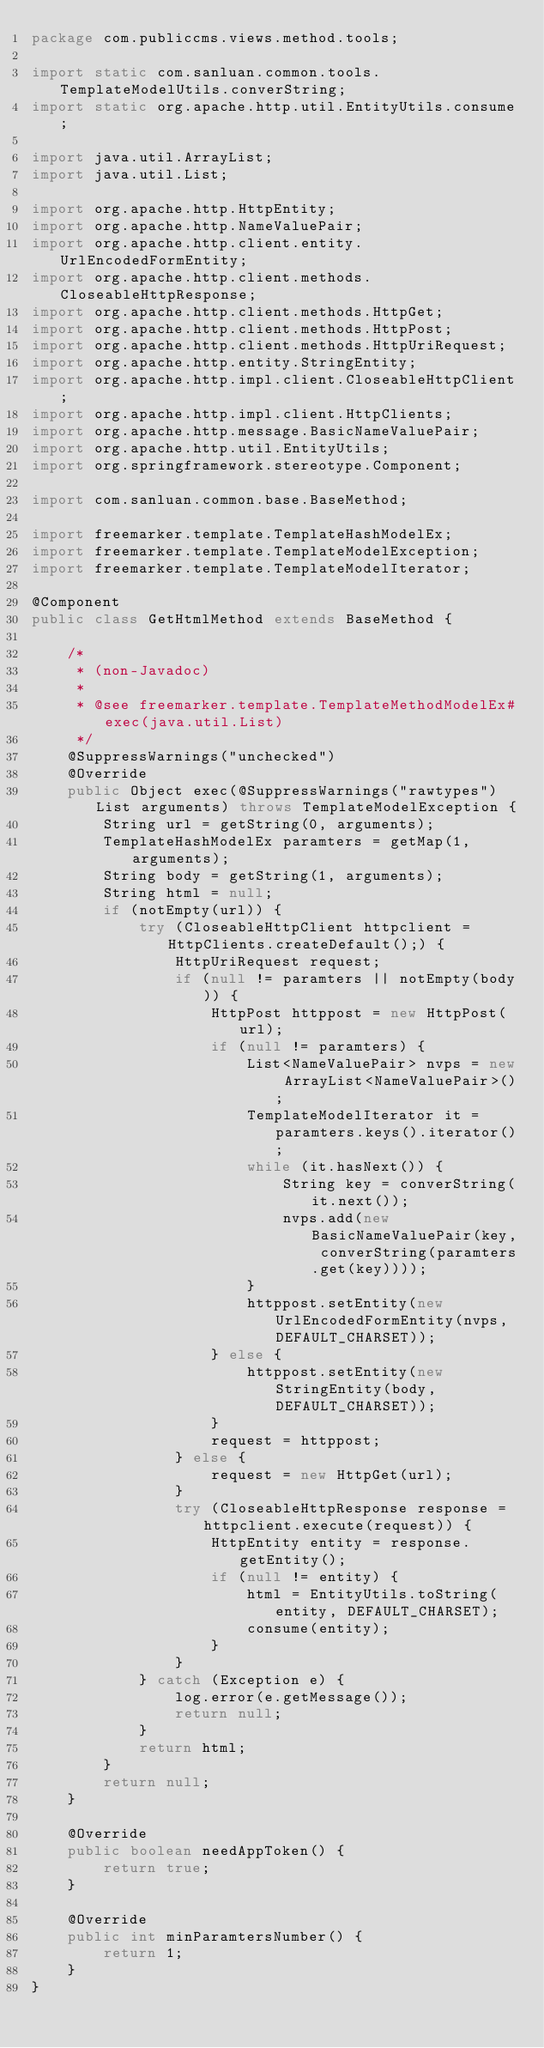<code> <loc_0><loc_0><loc_500><loc_500><_Java_>package com.publiccms.views.method.tools;

import static com.sanluan.common.tools.TemplateModelUtils.converString;
import static org.apache.http.util.EntityUtils.consume;

import java.util.ArrayList;
import java.util.List;

import org.apache.http.HttpEntity;
import org.apache.http.NameValuePair;
import org.apache.http.client.entity.UrlEncodedFormEntity;
import org.apache.http.client.methods.CloseableHttpResponse;
import org.apache.http.client.methods.HttpGet;
import org.apache.http.client.methods.HttpPost;
import org.apache.http.client.methods.HttpUriRequest;
import org.apache.http.entity.StringEntity;
import org.apache.http.impl.client.CloseableHttpClient;
import org.apache.http.impl.client.HttpClients;
import org.apache.http.message.BasicNameValuePair;
import org.apache.http.util.EntityUtils;
import org.springframework.stereotype.Component;

import com.sanluan.common.base.BaseMethod;

import freemarker.template.TemplateHashModelEx;
import freemarker.template.TemplateModelException;
import freemarker.template.TemplateModelIterator;

@Component
public class GetHtmlMethod extends BaseMethod {

    /*
     * (non-Javadoc)
     * 
     * @see freemarker.template.TemplateMethodModelEx#exec(java.util.List)
     */
    @SuppressWarnings("unchecked")
    @Override
    public Object exec(@SuppressWarnings("rawtypes") List arguments) throws TemplateModelException {
        String url = getString(0, arguments);
        TemplateHashModelEx paramters = getMap(1, arguments);
        String body = getString(1, arguments);
        String html = null;
        if (notEmpty(url)) {
            try (CloseableHttpClient httpclient = HttpClients.createDefault();) {
                HttpUriRequest request;
                if (null != paramters || notEmpty(body)) {
                    HttpPost httppost = new HttpPost(url);
                    if (null != paramters) {
                        List<NameValuePair> nvps = new ArrayList<NameValuePair>();
                        TemplateModelIterator it = paramters.keys().iterator();
                        while (it.hasNext()) {
                            String key = converString(it.next());
                            nvps.add(new BasicNameValuePair(key, converString(paramters.get(key))));
                        }
                        httppost.setEntity(new UrlEncodedFormEntity(nvps, DEFAULT_CHARSET));
                    } else {
                        httppost.setEntity(new StringEntity(body, DEFAULT_CHARSET));
                    }
                    request = httppost;
                } else {
                    request = new HttpGet(url);
                }
                try (CloseableHttpResponse response = httpclient.execute(request)) {
                    HttpEntity entity = response.getEntity();
                    if (null != entity) {
                        html = EntityUtils.toString(entity, DEFAULT_CHARSET);
                        consume(entity);
                    }
                }
            } catch (Exception e) {
                log.error(e.getMessage());
                return null;
            }
            return html;
        }
        return null;
    }

    @Override
    public boolean needAppToken() {
        return true;
    }

    @Override
    public int minParamtersNumber() {
        return 1;
    }
}
</code> 